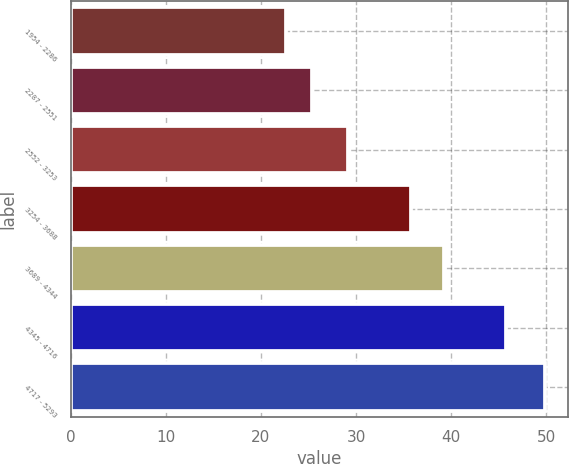Convert chart. <chart><loc_0><loc_0><loc_500><loc_500><bar_chart><fcel>1954 - 2286<fcel>2287 - 2551<fcel>2552 - 3253<fcel>3254 - 3688<fcel>3689 - 4344<fcel>4345 - 4716<fcel>4717 - 5293<nl><fcel>22.64<fcel>25.36<fcel>29.15<fcel>35.82<fcel>39.29<fcel>45.81<fcel>49.83<nl></chart> 